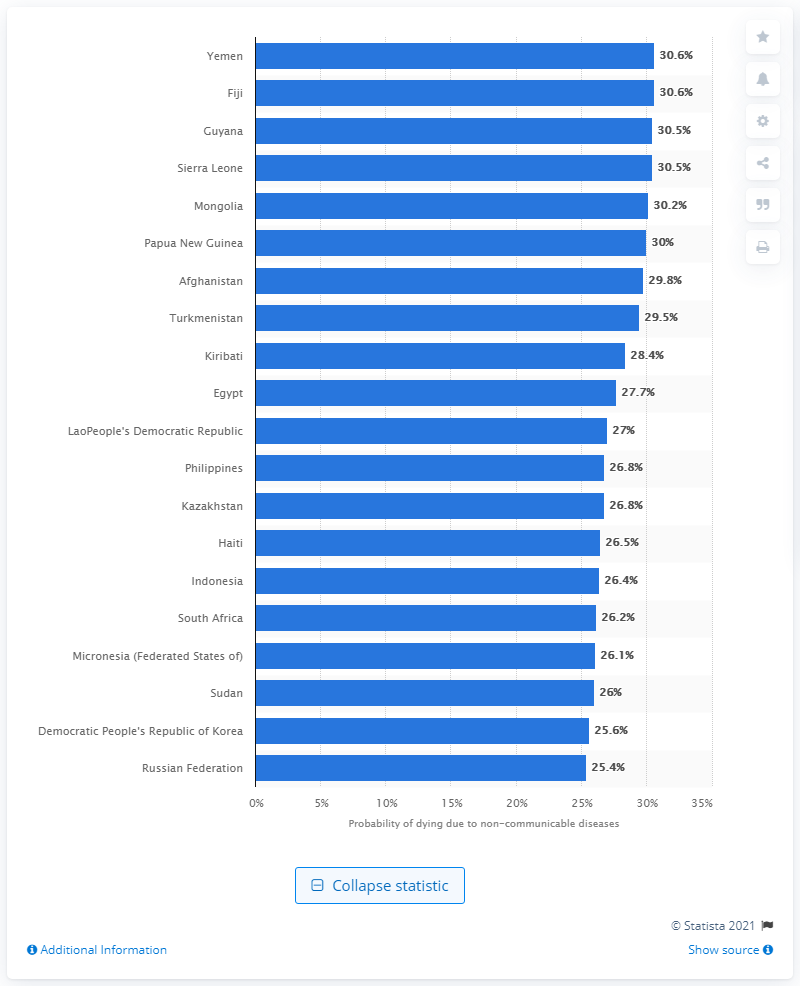Indicate a few pertinent items in this graphic. In 2016, the probability of dying from a non-communicable disease in Papua New Guinea was 30.2%. 